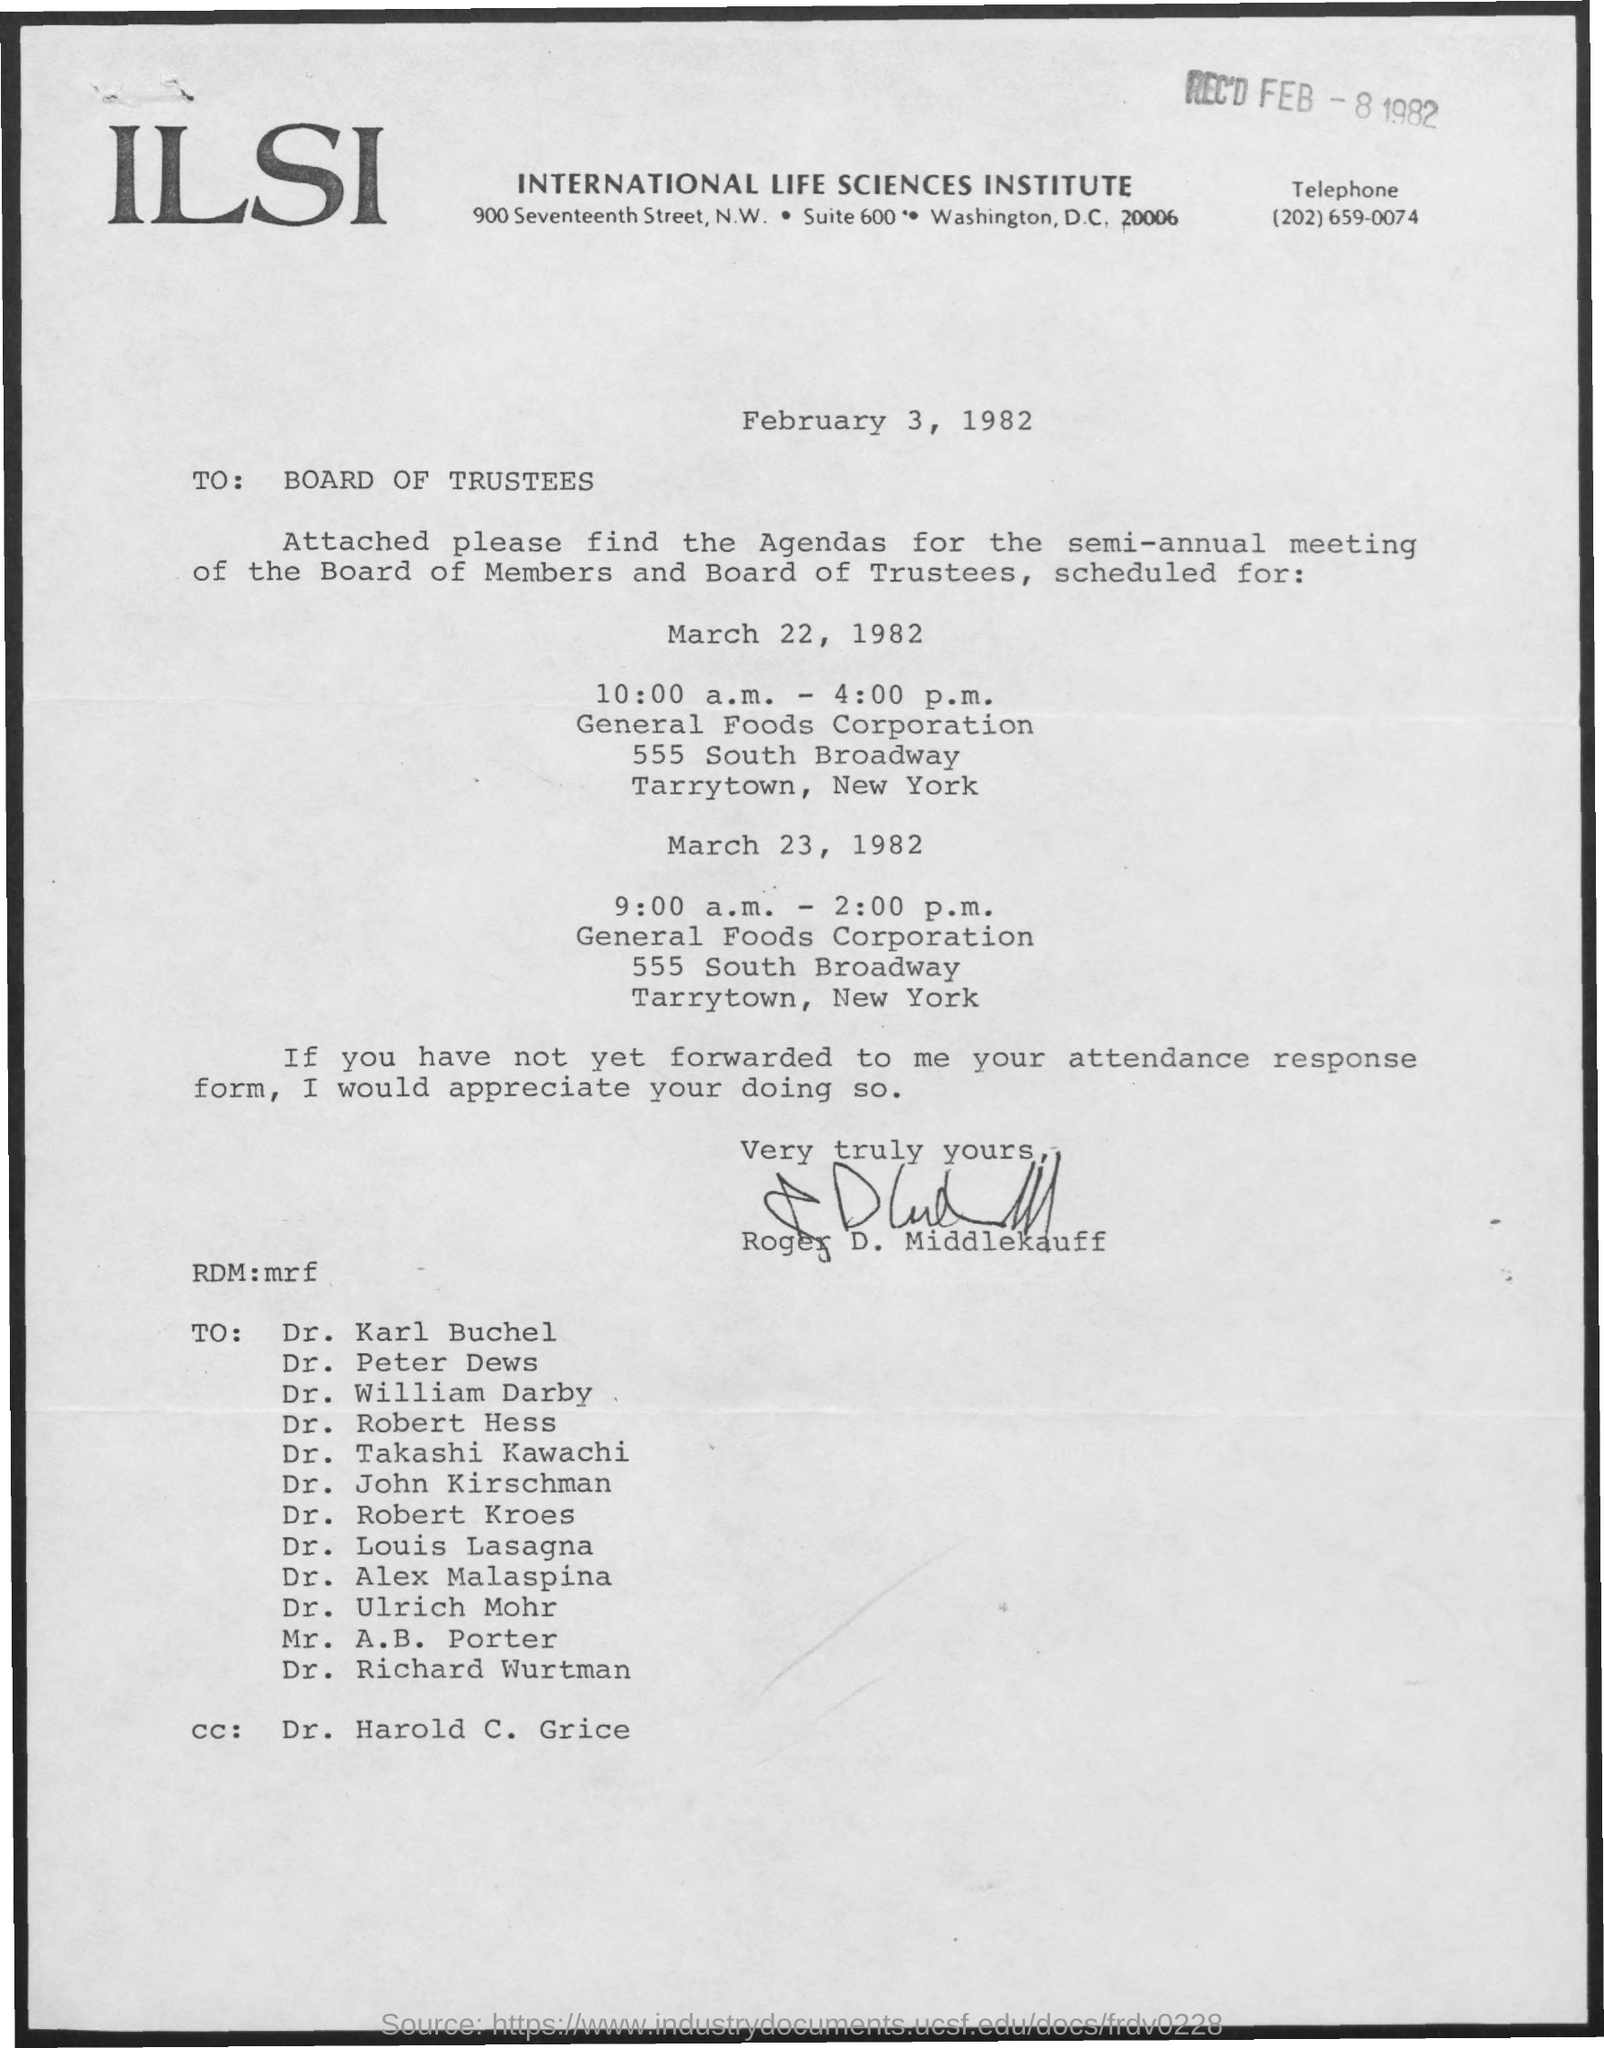Give some essential details in this illustration. Roger D. Middlekauff has signed the letter. The document is addressed to the Board of Trustees. The document is dated February 3, 1982. The recipient of the cc is Dr. Harold C. Grice. The document was received on February 8, 1982. 